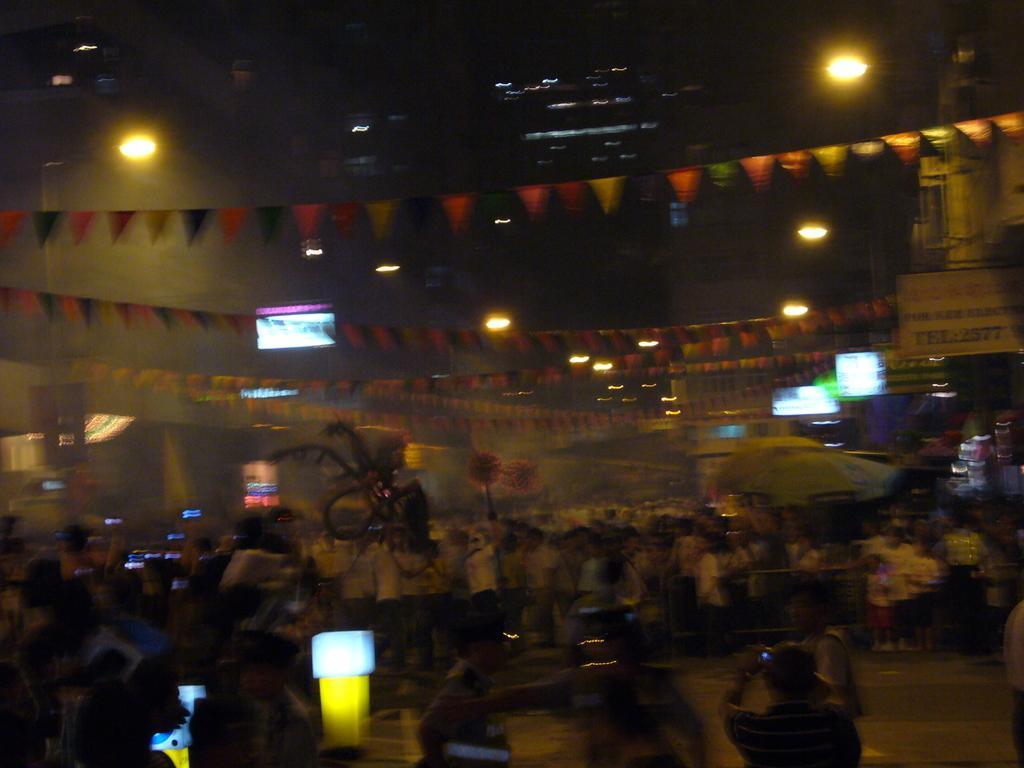Describe this image in one or two sentences. This picture is clicked outside. In the foreground we can see the group of persons and many other objects. In the background we can see the buildings, lights, flags hanging on the ropes and we can see the digital screens and the text on the boards and the street lights and many other objects. 